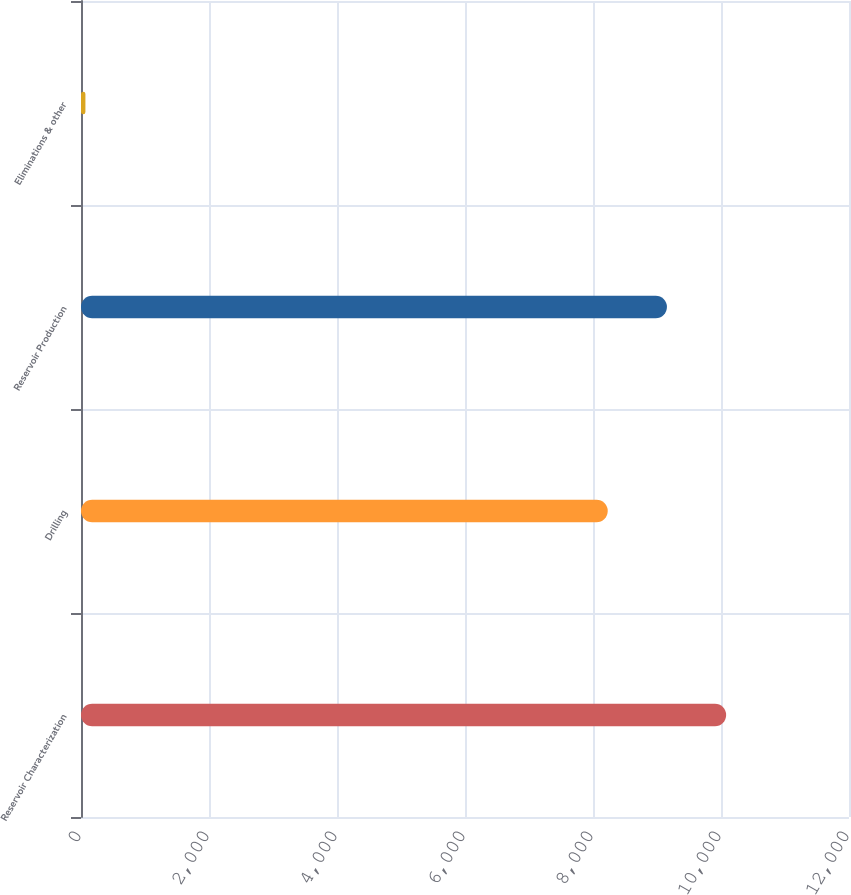<chart> <loc_0><loc_0><loc_500><loc_500><bar_chart><fcel>Reservoir Characterization<fcel>Drilling<fcel>Reservoir Production<fcel>Eliminations & other<nl><fcel>10080.4<fcel>8230<fcel>9155.2<fcel>69<nl></chart> 